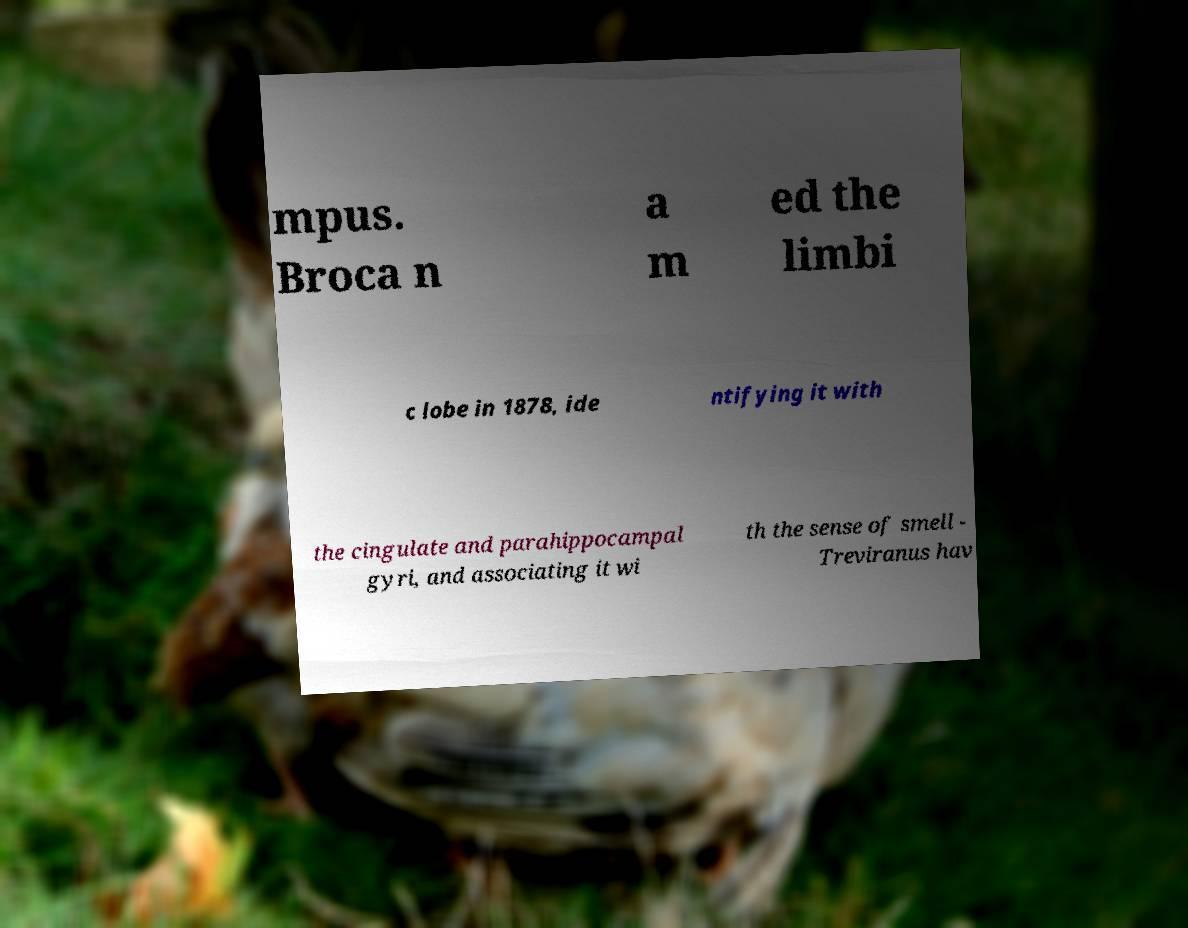Please identify and transcribe the text found in this image. mpus. Broca n a m ed the limbi c lobe in 1878, ide ntifying it with the cingulate and parahippocampal gyri, and associating it wi th the sense of smell - Treviranus hav 